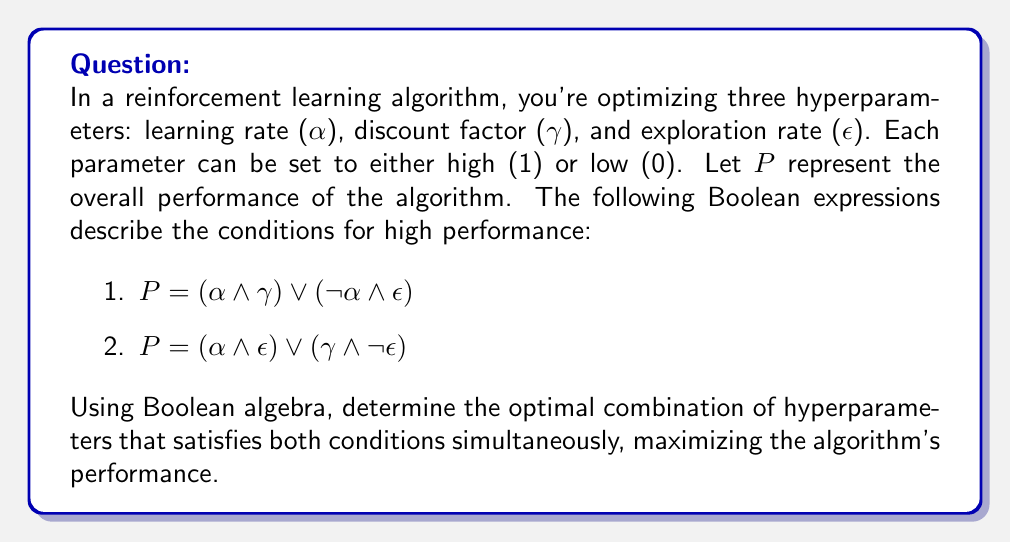Help me with this question. Let's approach this step-by-step using Boolean algebra:

1) We need to find a combination of $\alpha$, $\gamma$, and $\epsilon$ that makes both expressions true. This is equivalent to finding the conjunction (AND) of the two expressions:

   $P = [(\alpha \land \gamma) \lor (\neg \alpha \land \epsilon)] \land [(\alpha \land \epsilon) \lor (\gamma \land \neg \epsilon)]$

2) Let's expand this using the distributive property:

   $P = (\alpha \land \gamma \land \alpha \land \epsilon) \lor (\alpha \land \gamma \land \gamma \land \neg \epsilon) \lor (\neg \alpha \land \epsilon \land \alpha \land \epsilon) \lor (\neg \alpha \land \epsilon \land \gamma \land \neg \epsilon)$

3) Simplify using the idempotent law ($a \land a = a$) and the complement law ($a \land \neg a = 0$):

   $P = (\alpha \land \gamma \land \epsilon) \lor (\alpha \land \gamma \land \neg \epsilon) \lor (0) \lor (0)$

4) Further simplify:

   $P = (\alpha \land \gamma \land \epsilon) \lor (\alpha \land \gamma \land \neg \epsilon)$

5) Factor out the common term:

   $P = \alpha \land \gamma \land (\epsilon \lor \neg \epsilon)$

6) Simplify using the law of excluded middle ($a \lor \neg a = 1$):

   $P = \alpha \land \gamma$

This final expression tells us that for optimal performance, we need both $\alpha$ (learning rate) and $\gamma$ (discount factor) to be high (1), while $\epsilon$ (exploration rate) can be either high or low.
Answer: $\alpha = 1, \gamma = 1, \epsilon = \text{any}$ 